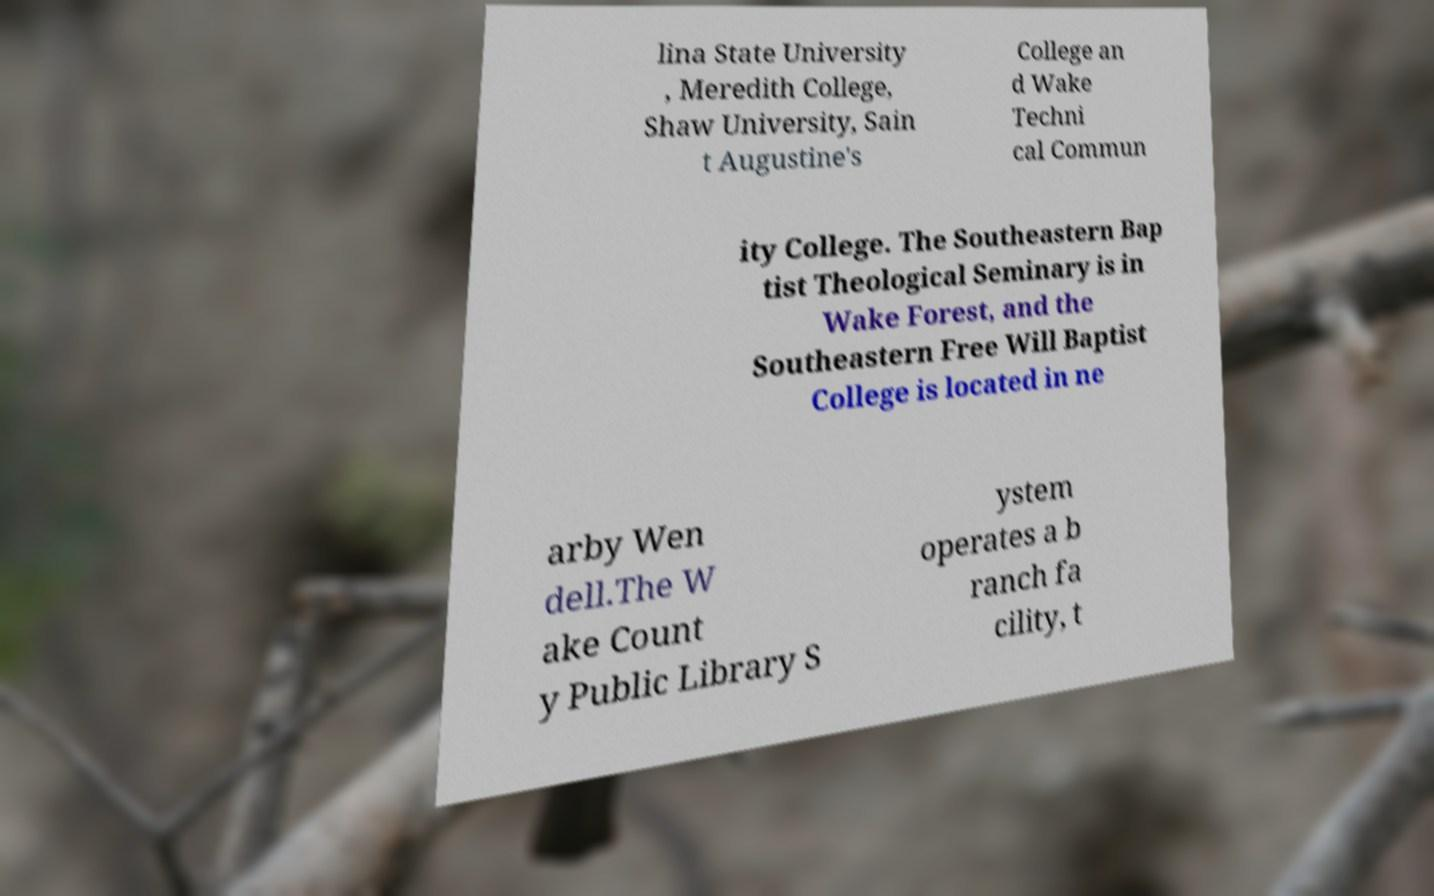Could you extract and type out the text from this image? lina State University , Meredith College, Shaw University, Sain t Augustine's College an d Wake Techni cal Commun ity College. The Southeastern Bap tist Theological Seminary is in Wake Forest, and the Southeastern Free Will Baptist College is located in ne arby Wen dell.The W ake Count y Public Library S ystem operates a b ranch fa cility, t 